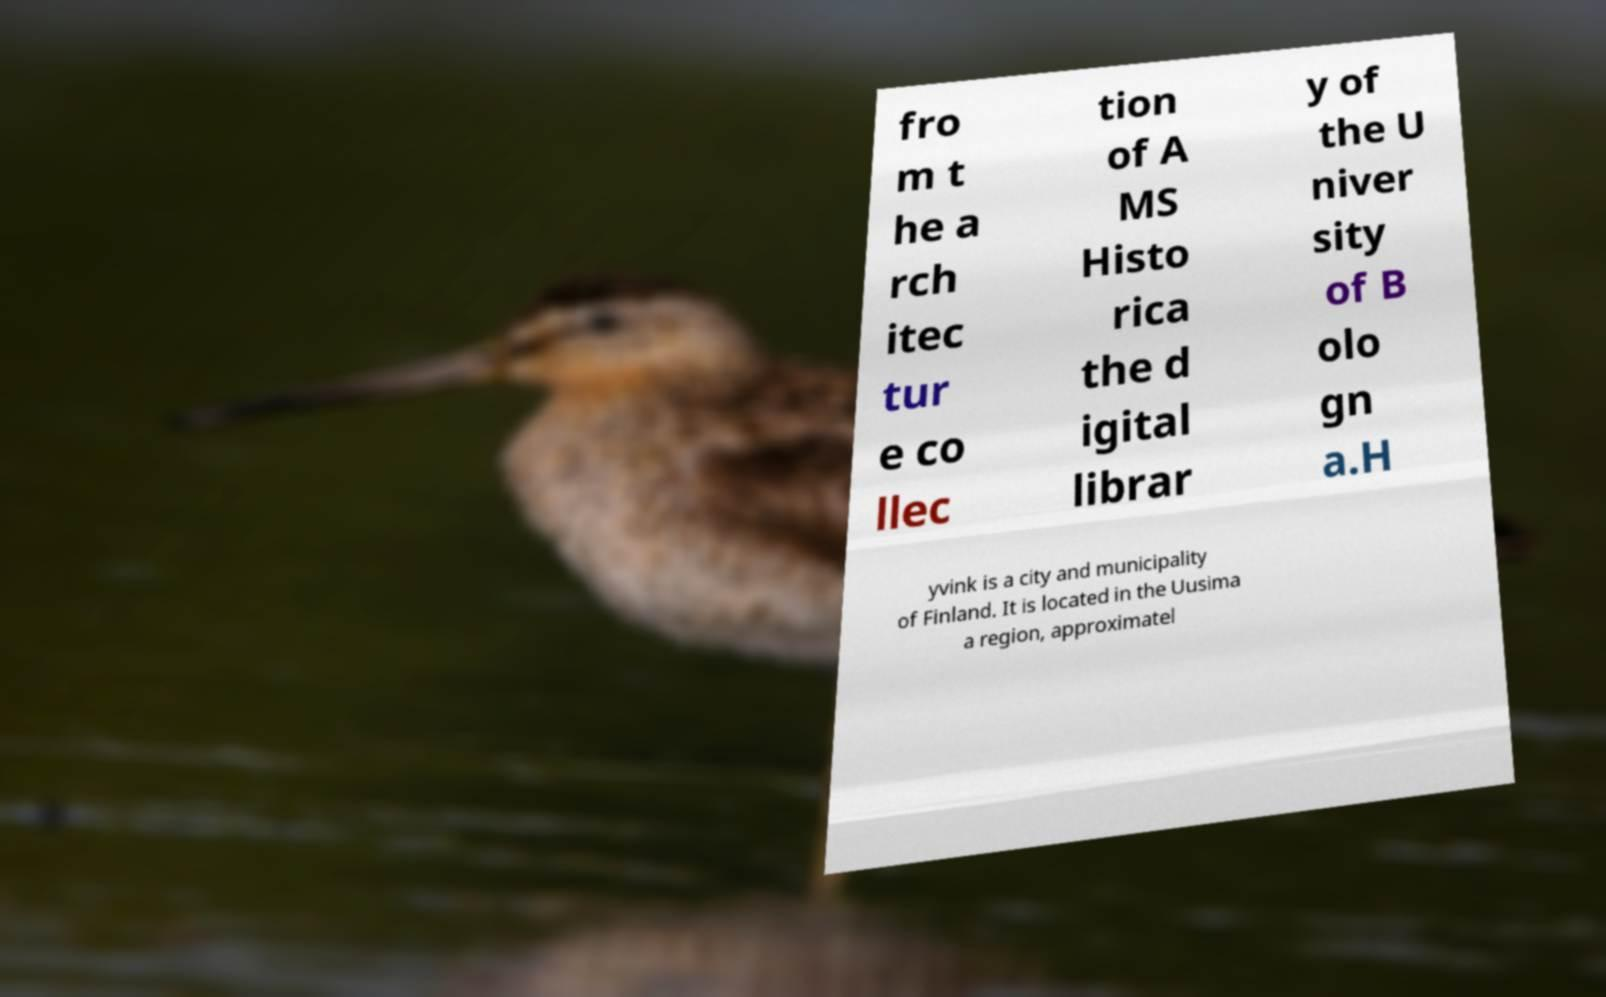What messages or text are displayed in this image? I need them in a readable, typed format. fro m t he a rch itec tur e co llec tion of A MS Histo rica the d igital librar y of the U niver sity of B olo gn a.H yvink is a city and municipality of Finland. It is located in the Uusima a region, approximatel 